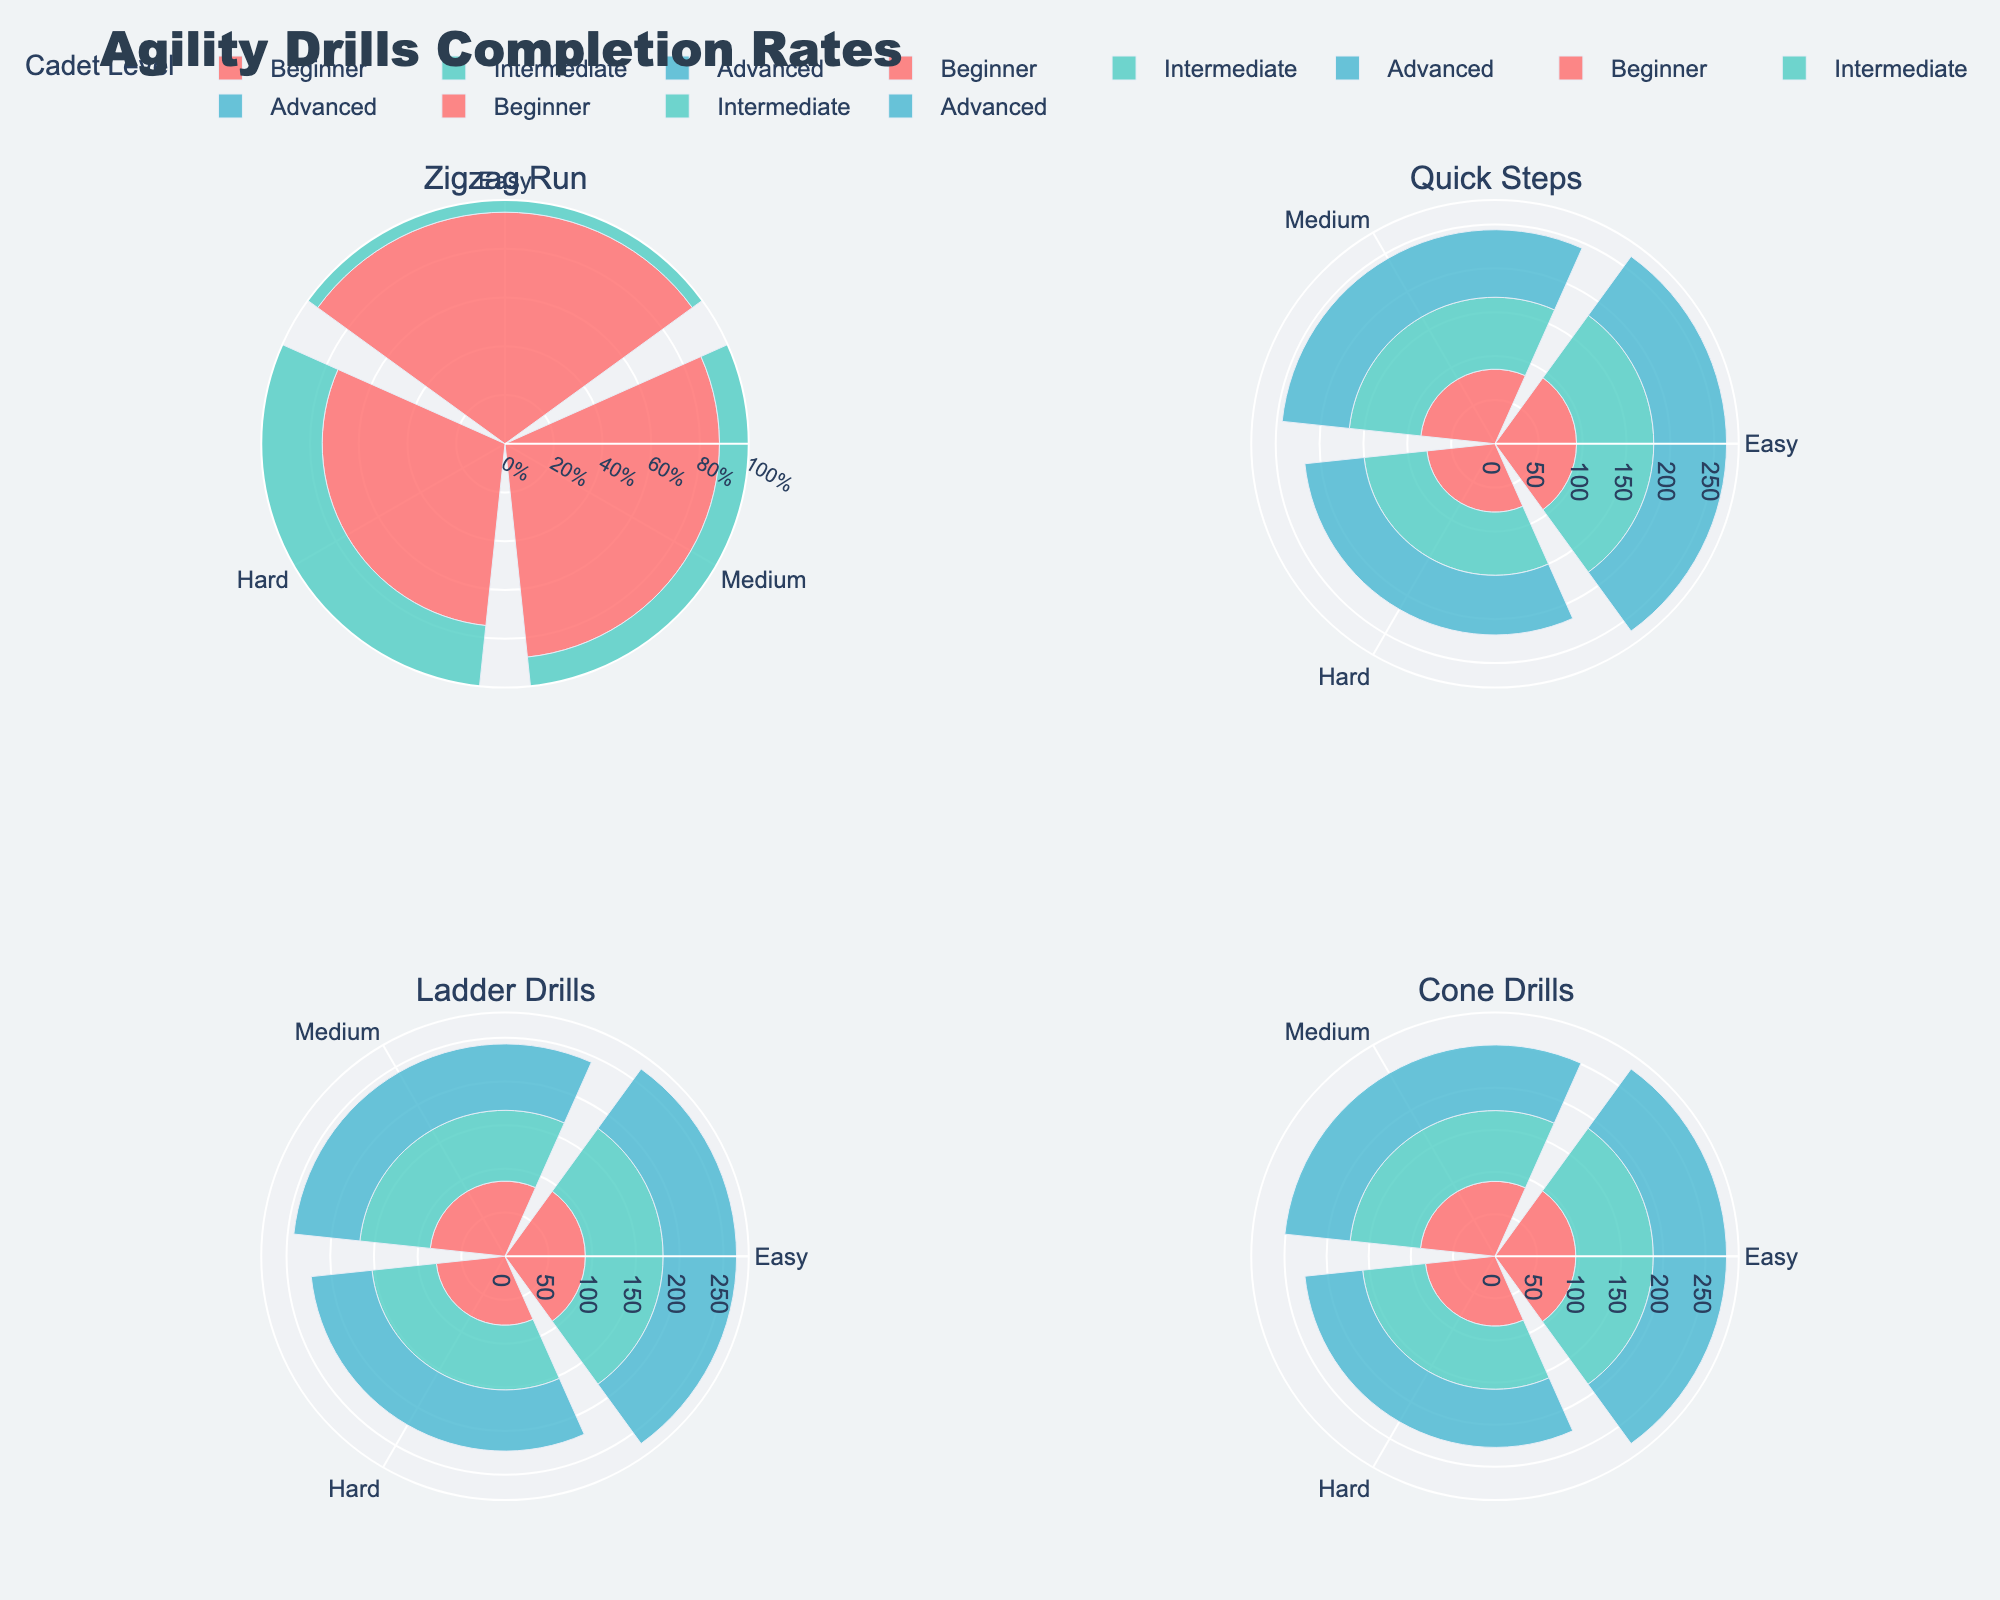What is the completion rate for the Zigzag Run drill at the beginner level on easy difficulty? Look at the Zigzag Run subplot and find the bar corresponding to the beginner level and easy difficulty. The completion rate is shown on the radial axis.
Answer: 95% How does the completion rate compare between intermediate and advanced levels for Ladder Drills on medium difficulty? Find the Ladder Drills subplot and locate the bars for medium difficulty at both intermediate and advanced levels. Compare the radial values shown on the bars.
Answer: Intermediate: 81%, Advanced: 76% Which drill has the highest completion rate on hard difficulty at the beginner level? Check all subplots for beginner levels with hard difficulty. Compare their radial values to identify the highest one.
Answer: Cone Drills What is the average completion rate for Quick Steps at the advanced level across all difficulties? For Quick Steps at the advanced level, add the completion rates for all difficulties (easy, medium, hard) and divide by the number of difficulties. (83% + 77% + 68%)/3
Answer: 76% How does the completion rate for easy difficulties change from beginner to advanced levels in Zigzag Run? In the Zigzag Run subplot, observe the easy difficulty bars for all levels. Note the radial values for the beginner, intermediate, and advanced levels and describe their trend.
Answer: Beginner: 95%, Intermediate: 90%, Advanced: 85% Which drill has the smallest difference in completion rate between beginner and intermediate levels on medium difficulty? For each drill, find the medium difficulty bars for both beginner and intermediate levels. Calculate the differences and identify the smallest one.
Answer: Cone Drills (89% - 84% = 5%) Is there any drill where the completion rate at the advanced level and hard difficulty is less than 70%? Look at all subplots for the advanced level and hard difficulty bars, and check if any value is below 70%.
Answer: Yes, Zigzag Run What is the completion rate trend for Ladder Drills on easy difficulty from beginner to advanced levels? In the Ladder Drills subplot, note the completion rates for easy difficulty across beginner, intermediate, and advanced levels. Describe the pattern: Beginner (92%), Intermediate (89%), Advanced (84%).
Answer: Decreasing How many different levels are represented in the plots? Identify the unique levels (Beginner, Intermediate, Advanced) shown in any of the subplots.
Answer: 3 Which drill has the lowest completion rate for intermediate level on hard difficulty? Scan all subplots for intermediate level and hard difficulty bars. Identify the lowest radial value.
Answer: Zigzag Run 